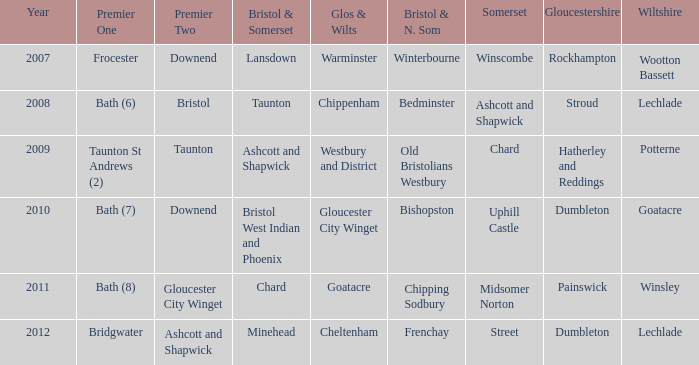What is the somerset for the year 2009? Chard. 